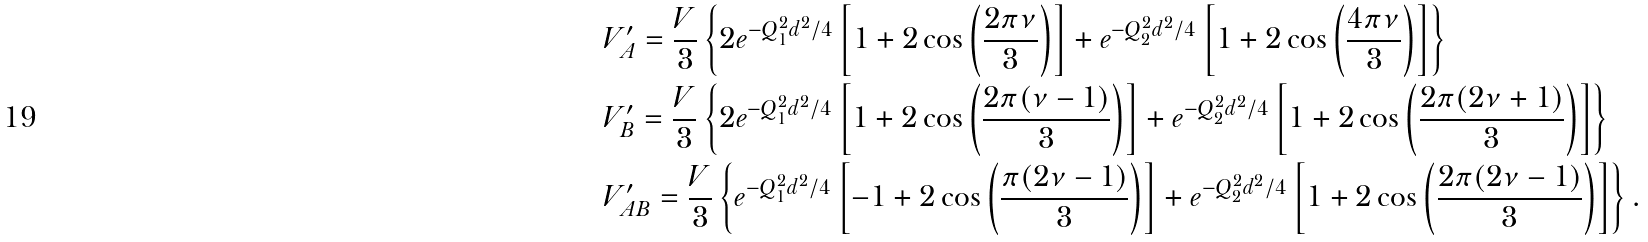<formula> <loc_0><loc_0><loc_500><loc_500>& V _ { A } ^ { \prime } = \frac { V } { 3 } \left \{ 2 e ^ { - Q _ { 1 } ^ { 2 } d ^ { 2 } / 4 } \left [ 1 + 2 \cos \left ( \frac { 2 \pi \nu } { 3 } \right ) \right ] + e ^ { - Q _ { 2 } ^ { 2 } d ^ { 2 } / 4 } \left [ 1 + 2 \cos \left ( \frac { 4 \pi \nu } { 3 } \right ) \right ] \right \} \\ & V _ { B } ^ { \prime } = \frac { V } { 3 } \left \{ 2 e ^ { - Q _ { 1 } ^ { 2 } d ^ { 2 } / 4 } \left [ 1 + 2 \cos \left ( \frac { 2 \pi ( \nu - 1 ) } { 3 } \right ) \right ] + e ^ { - Q _ { 2 } ^ { 2 } d ^ { 2 } / 4 } \left [ 1 + 2 \cos \left ( \frac { 2 \pi ( 2 \nu + 1 ) } { 3 } \right ) \right ] \right \} \\ & V ^ { \prime } _ { A B } = \frac { V } { 3 } \left \{ e ^ { - Q _ { 1 } ^ { 2 } d ^ { 2 } / 4 } \left [ - 1 + 2 \cos \left ( \frac { \pi ( 2 \nu - 1 ) } { 3 } \right ) \right ] + e ^ { - Q _ { 2 } ^ { 2 } d ^ { 2 } / 4 } \left [ 1 + 2 \cos \left ( \frac { 2 \pi ( 2 \nu - 1 ) } { 3 } \right ) \right ] \right \} .</formula> 